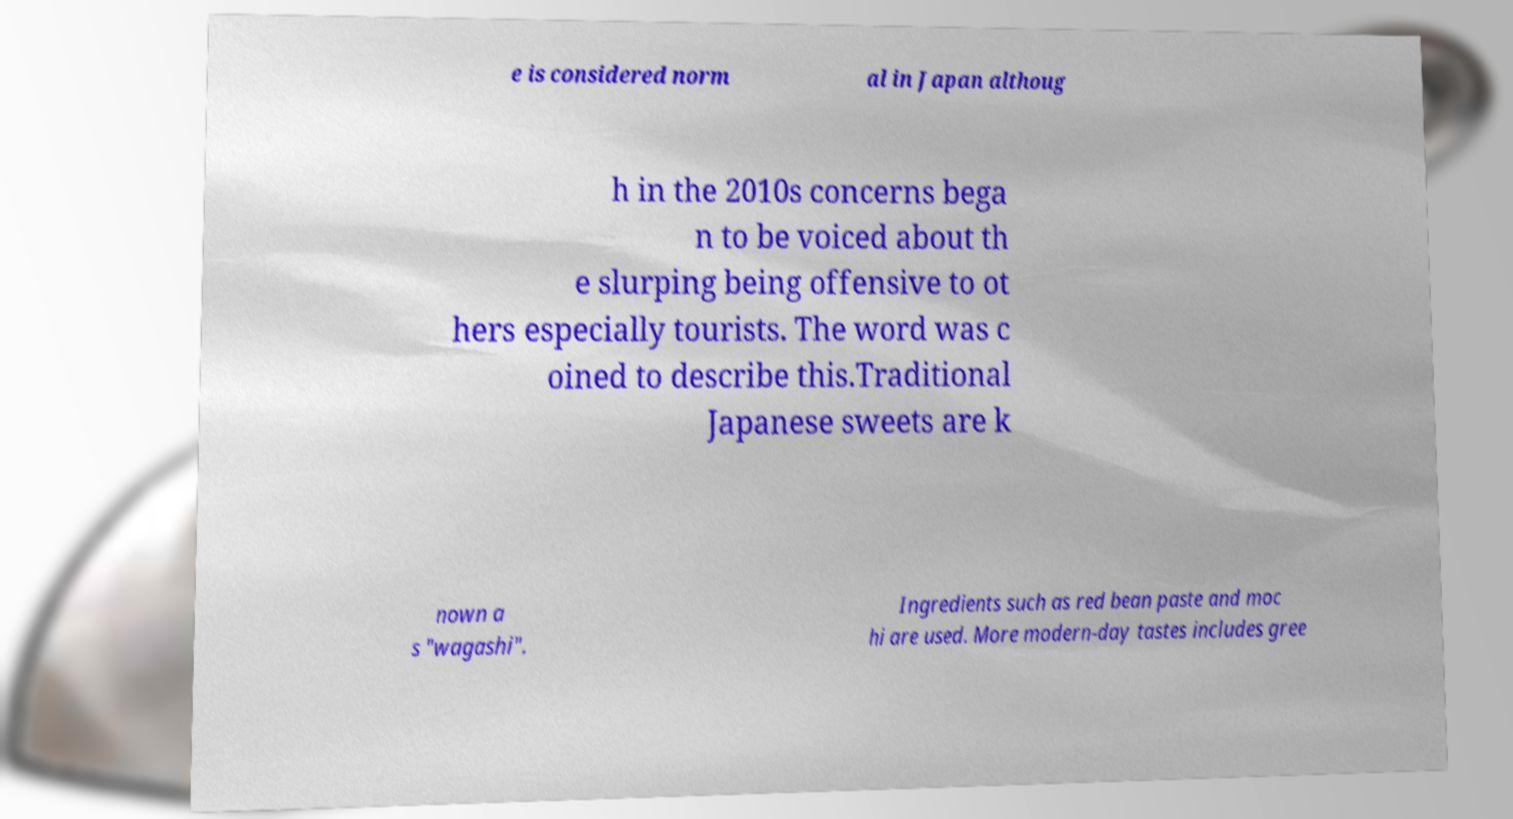Please read and relay the text visible in this image. What does it say? e is considered norm al in Japan althoug h in the 2010s concerns bega n to be voiced about th e slurping being offensive to ot hers especially tourists. The word was c oined to describe this.Traditional Japanese sweets are k nown a s "wagashi". Ingredients such as red bean paste and moc hi are used. More modern-day tastes includes gree 